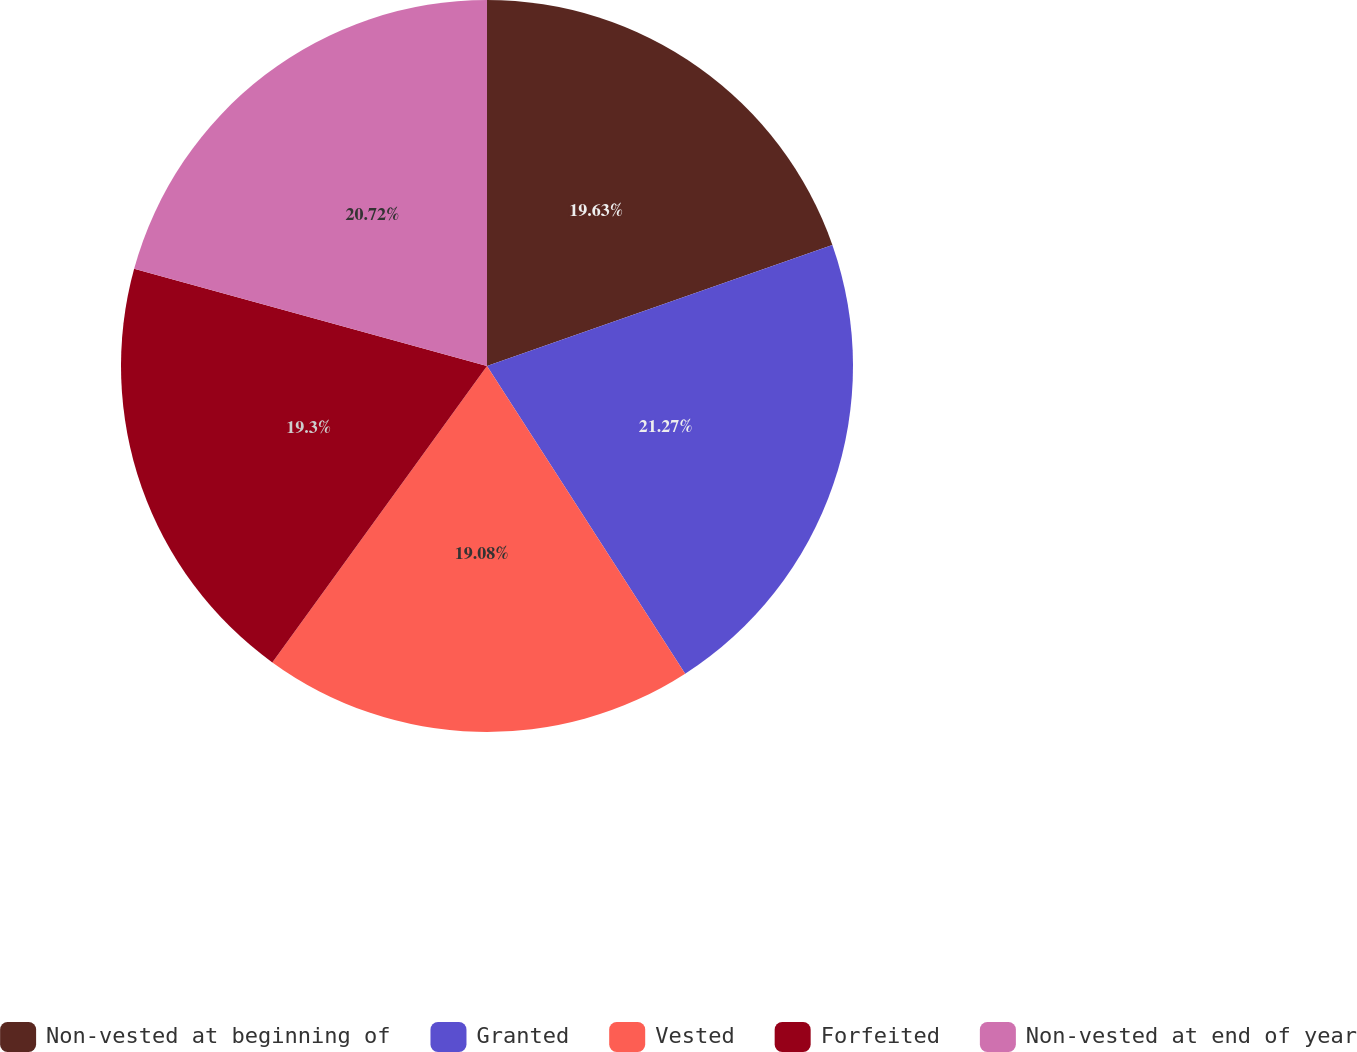Convert chart. <chart><loc_0><loc_0><loc_500><loc_500><pie_chart><fcel>Non-vested at beginning of<fcel>Granted<fcel>Vested<fcel>Forfeited<fcel>Non-vested at end of year<nl><fcel>19.63%<fcel>21.26%<fcel>19.08%<fcel>19.3%<fcel>20.72%<nl></chart> 